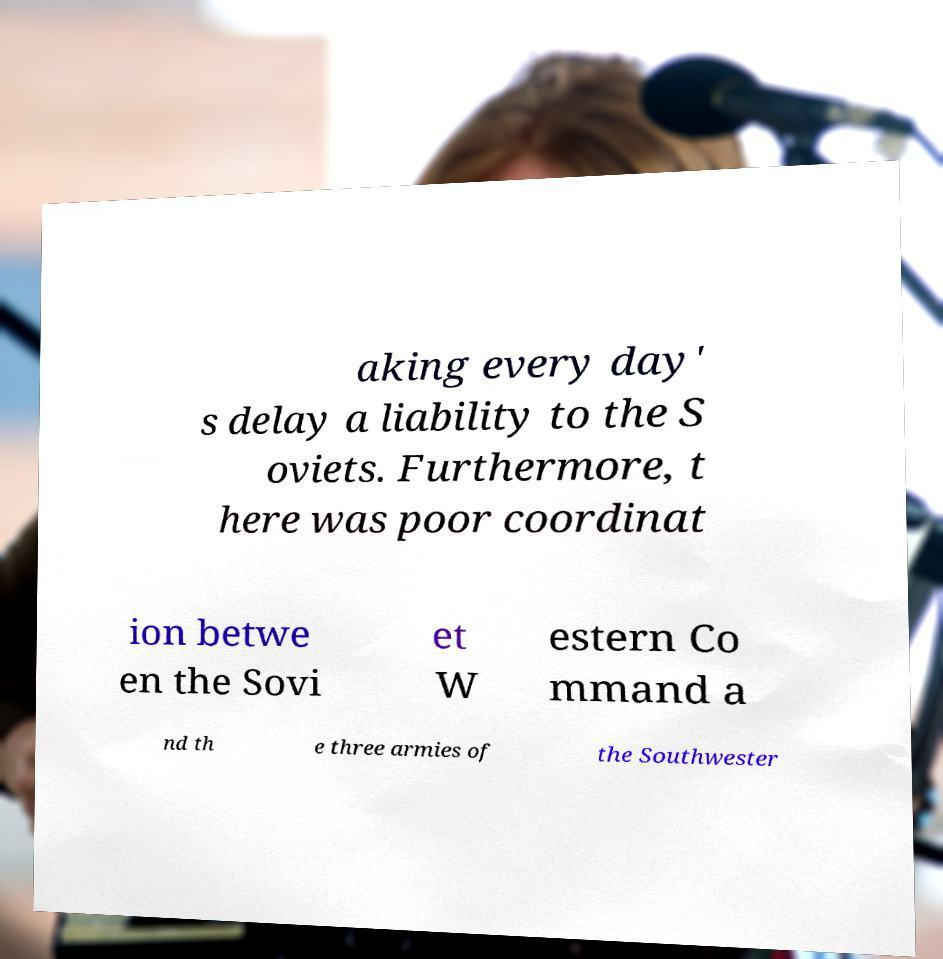For documentation purposes, I need the text within this image transcribed. Could you provide that? aking every day' s delay a liability to the S oviets. Furthermore, t here was poor coordinat ion betwe en the Sovi et W estern Co mmand a nd th e three armies of the Southwester 